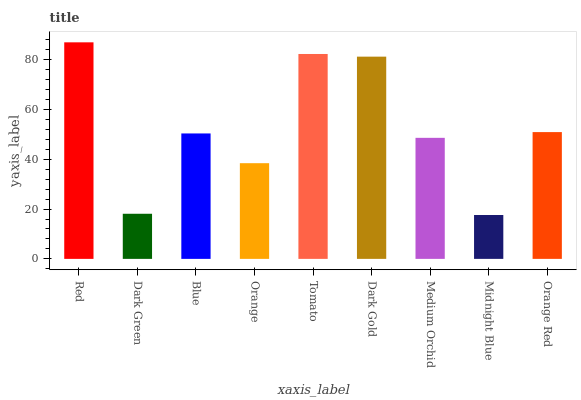Is Midnight Blue the minimum?
Answer yes or no. Yes. Is Red the maximum?
Answer yes or no. Yes. Is Dark Green the minimum?
Answer yes or no. No. Is Dark Green the maximum?
Answer yes or no. No. Is Red greater than Dark Green?
Answer yes or no. Yes. Is Dark Green less than Red?
Answer yes or no. Yes. Is Dark Green greater than Red?
Answer yes or no. No. Is Red less than Dark Green?
Answer yes or no. No. Is Blue the high median?
Answer yes or no. Yes. Is Blue the low median?
Answer yes or no. Yes. Is Dark Green the high median?
Answer yes or no. No. Is Red the low median?
Answer yes or no. No. 